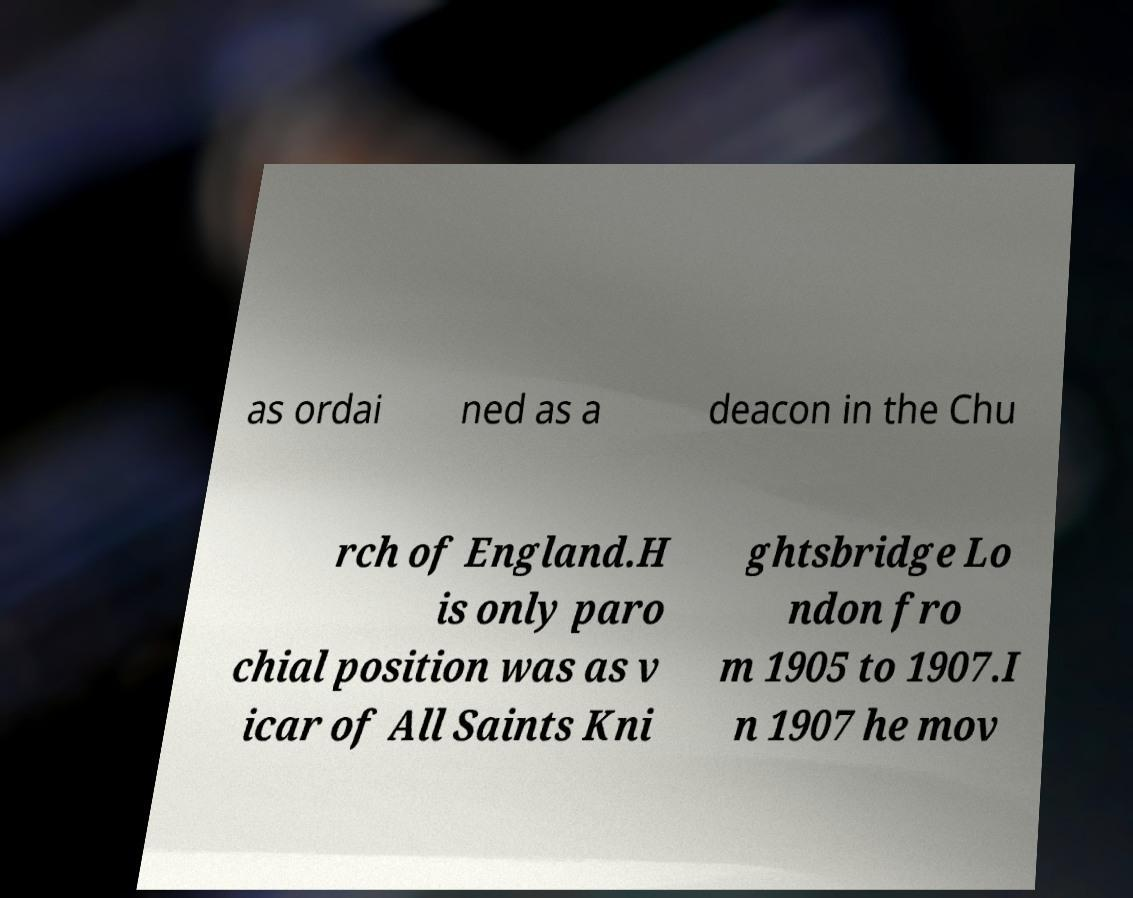Can you read and provide the text displayed in the image?This photo seems to have some interesting text. Can you extract and type it out for me? as ordai ned as a deacon in the Chu rch of England.H is only paro chial position was as v icar of All Saints Kni ghtsbridge Lo ndon fro m 1905 to 1907.I n 1907 he mov 